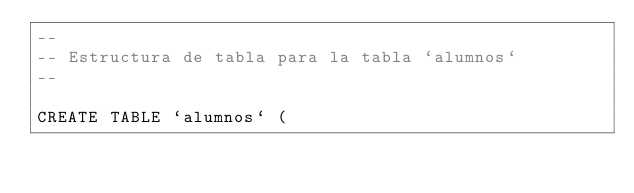Convert code to text. <code><loc_0><loc_0><loc_500><loc_500><_SQL_>--
-- Estructura de tabla para la tabla `alumnos`
--

CREATE TABLE `alumnos` (</code> 